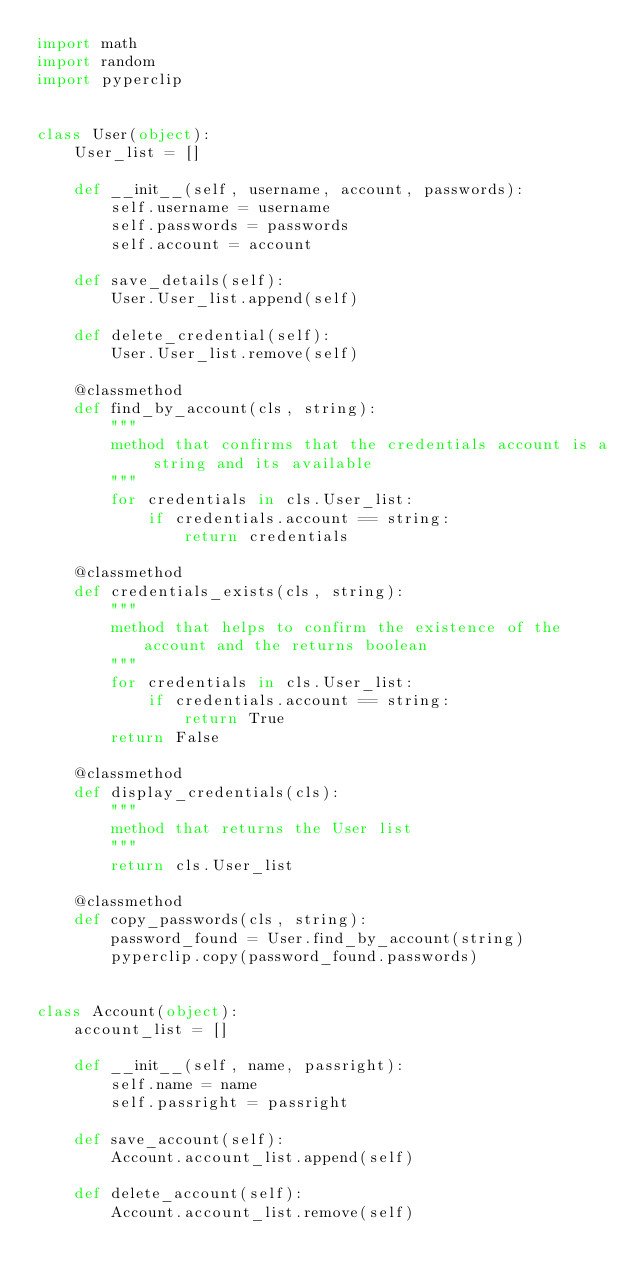Convert code to text. <code><loc_0><loc_0><loc_500><loc_500><_Python_>import math
import random
import pyperclip


class User(object):
    User_list = []

    def __init__(self, username, account, passwords):
        self.username = username
        self.passwords = passwords
        self.account = account

    def save_details(self):
        User.User_list.append(self)

    def delete_credential(self):
        User.User_list.remove(self)

    @classmethod
    def find_by_account(cls, string):
        """
        method that confirms that the credentials account is a string and its available
        """
        for credentials in cls.User_list:
            if credentials.account == string:
                return credentials

    @classmethod
    def credentials_exists(cls, string):
        """
        method that helps to confirm the existence of the account and the returns boolean
        """
        for credentials in cls.User_list:
            if credentials.account == string:
                return True
        return False

    @classmethod
    def display_credentials(cls):
        """
        method that returns the User list
        """
        return cls.User_list

    @classmethod
    def copy_passwords(cls, string):
        password_found = User.find_by_account(string)
        pyperclip.copy(password_found.passwords)


class Account(object):
    account_list = []

    def __init__(self, name, passright):
        self.name = name
        self.passright = passright

    def save_account(self):
        Account.account_list.append(self)

    def delete_account(self):
        Account.account_list.remove(self)</code> 